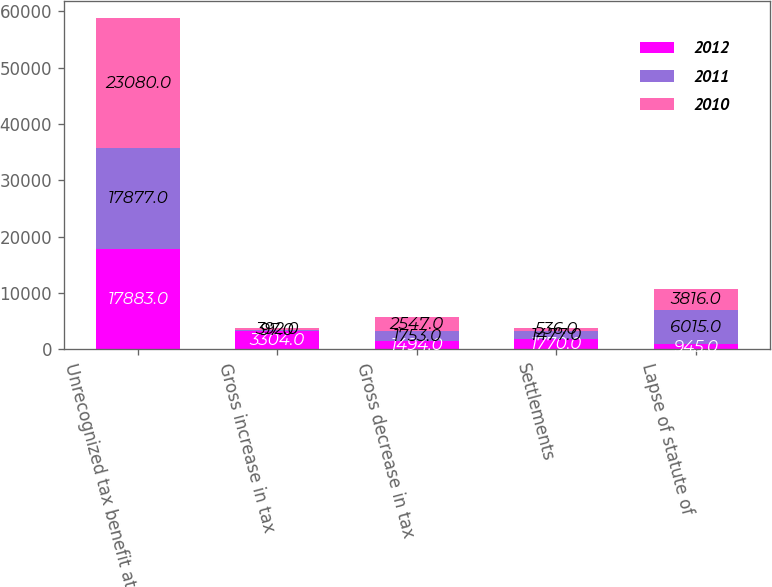<chart> <loc_0><loc_0><loc_500><loc_500><stacked_bar_chart><ecel><fcel>Unrecognized tax benefit at<fcel>Gross increase in tax<fcel>Gross decrease in tax<fcel>Settlements<fcel>Lapse of statute of<nl><fcel>2012<fcel>17883<fcel>3304<fcel>1494<fcel>1770<fcel>945<nl><fcel>2011<fcel>17877<fcel>97<fcel>1753<fcel>1477<fcel>6015<nl><fcel>2010<fcel>23080<fcel>392<fcel>2547<fcel>536<fcel>3816<nl></chart> 